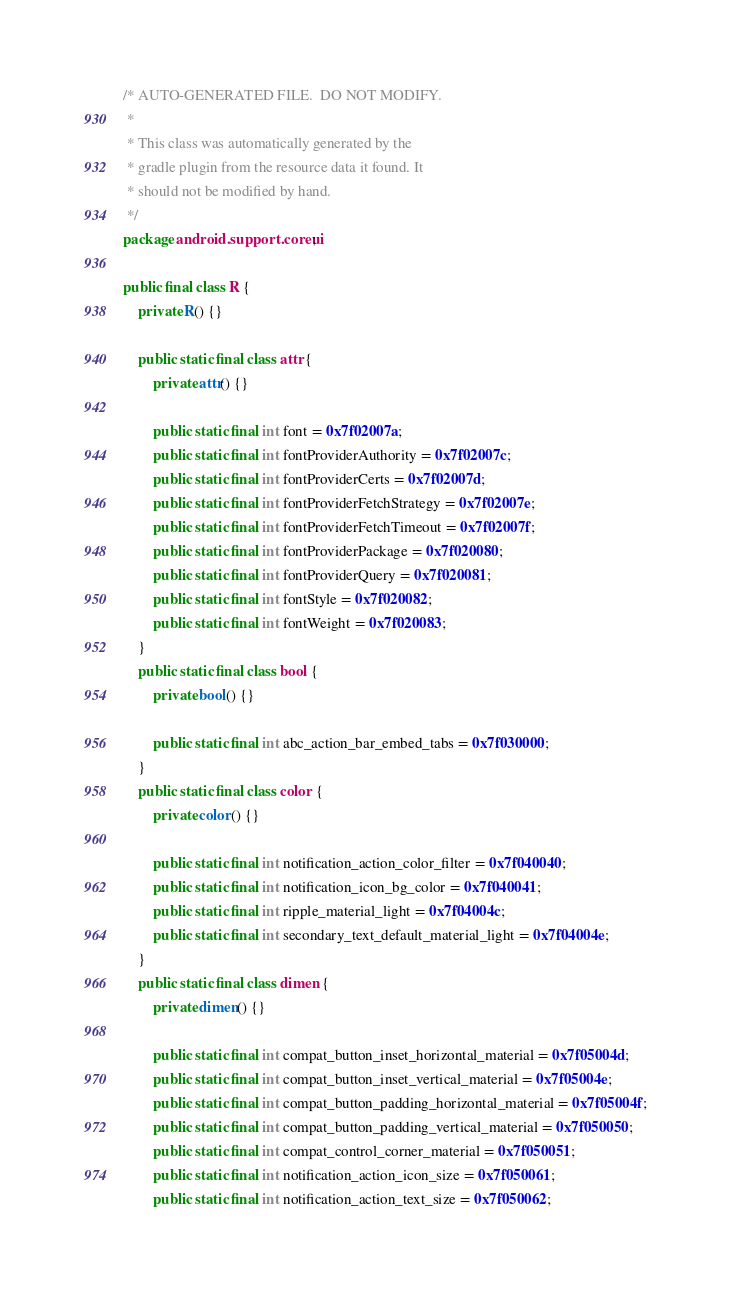Convert code to text. <code><loc_0><loc_0><loc_500><loc_500><_Java_>/* AUTO-GENERATED FILE.  DO NOT MODIFY.
 *
 * This class was automatically generated by the
 * gradle plugin from the resource data it found. It
 * should not be modified by hand.
 */
package android.support.coreui;

public final class R {
    private R() {}

    public static final class attr {
        private attr() {}

        public static final int font = 0x7f02007a;
        public static final int fontProviderAuthority = 0x7f02007c;
        public static final int fontProviderCerts = 0x7f02007d;
        public static final int fontProviderFetchStrategy = 0x7f02007e;
        public static final int fontProviderFetchTimeout = 0x7f02007f;
        public static final int fontProviderPackage = 0x7f020080;
        public static final int fontProviderQuery = 0x7f020081;
        public static final int fontStyle = 0x7f020082;
        public static final int fontWeight = 0x7f020083;
    }
    public static final class bool {
        private bool() {}

        public static final int abc_action_bar_embed_tabs = 0x7f030000;
    }
    public static final class color {
        private color() {}

        public static final int notification_action_color_filter = 0x7f040040;
        public static final int notification_icon_bg_color = 0x7f040041;
        public static final int ripple_material_light = 0x7f04004c;
        public static final int secondary_text_default_material_light = 0x7f04004e;
    }
    public static final class dimen {
        private dimen() {}

        public static final int compat_button_inset_horizontal_material = 0x7f05004d;
        public static final int compat_button_inset_vertical_material = 0x7f05004e;
        public static final int compat_button_padding_horizontal_material = 0x7f05004f;
        public static final int compat_button_padding_vertical_material = 0x7f050050;
        public static final int compat_control_corner_material = 0x7f050051;
        public static final int notification_action_icon_size = 0x7f050061;
        public static final int notification_action_text_size = 0x7f050062;</code> 